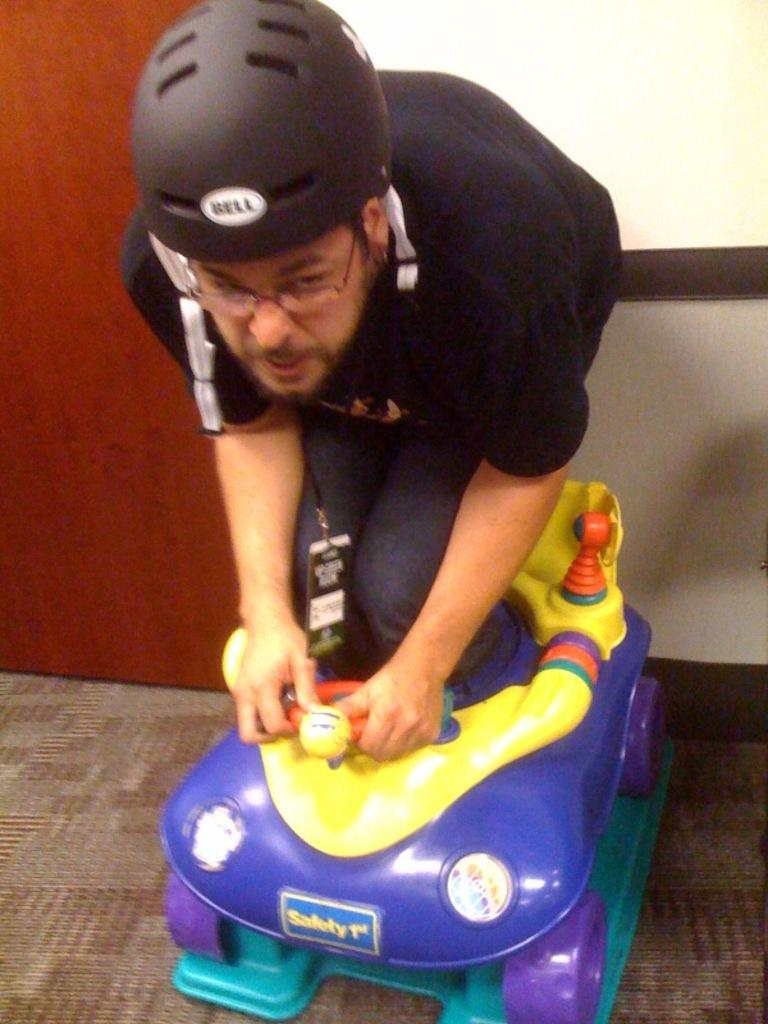Who is present in the image? There is a man in the image. What is the man doing in the image? The man is standing in a toy car. What is the man wearing in the image? The man is wearing a helmet. What can be seen in the background of the image? There is a wall and a door in the background of the image. How does the stranger ring the bell in the image? There is no stranger or bell present in the image. 